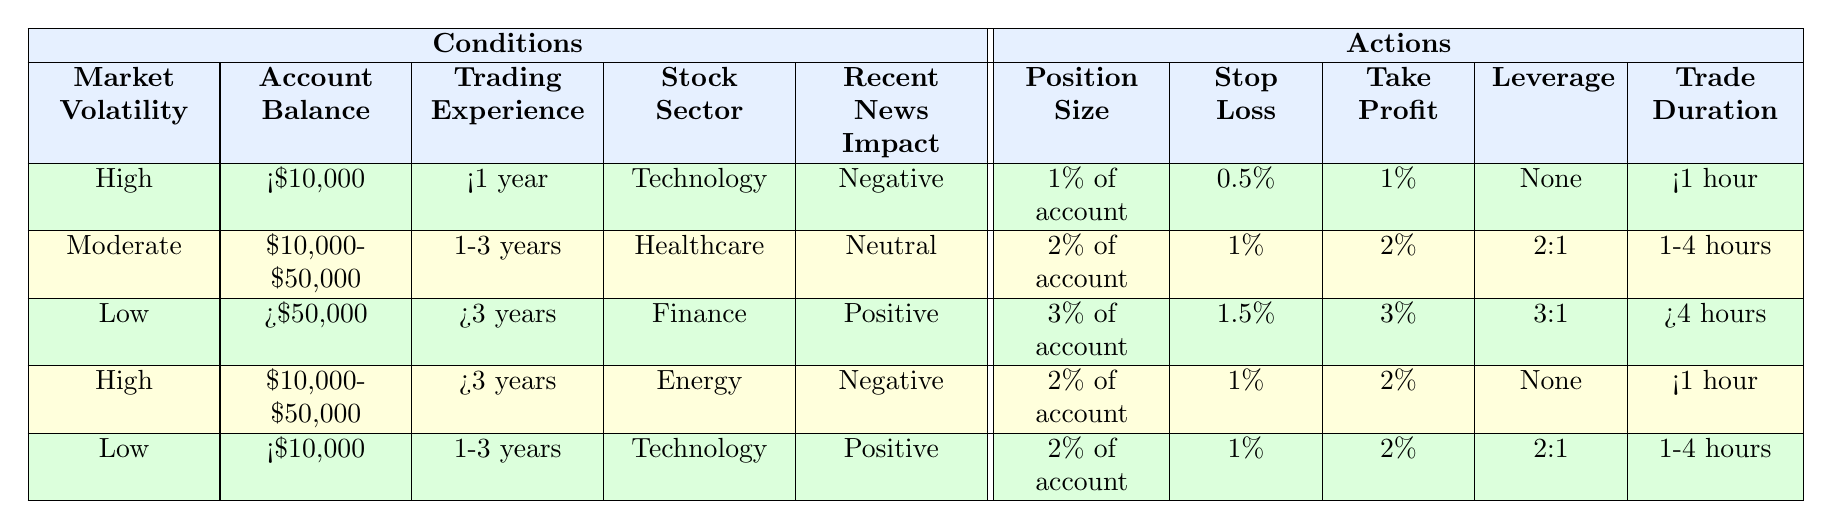What is the recommended position size for someone with less than $10,000 account balance and less than 1 year of trading experience in the technology sector when the market volatility is high and the recent news impact is negative? According to the table, the conditions are: High market volatility, account balance of less than $10,000, trading experience of less than 1 year, sector being Technology, and recent news impact as Negative. The actions for these conditions specify a position size of "1% of account."
Answer: 1% of account What is the stop-loss recommendation for someone with $10,000 to $50,000 account balance and more than 3 years of trading experience if they are trading in the energy sector with negative recent news? The relevant conditions in the table indicate a stop-loss of "1%" for the situation where there is High market volatility, an account balance of $10,000 to $50,000, trading experience over 3 years, Energy sector, and Negative news impact.
Answer: 1% Is it true that for a trader with a more than $50,000 account balance and more than 3 years of experience in finance, the take profit is set to 3%? Referencing the table, the conditions indicate Low market volatility, an account balance greater than $50,000, more than 3 years of experience, Finance sector, and Positive news impact. For these conditions, the take profit is specified as "3%." The statement is true.
Answer: Yes What is the average take profit percentage for trades in the healthcare sector regardless of account balance, trading experience, and news impact? Analyzing the table, there is only one associated percentage for take profit when trading in the healthcare sector, which is "2%" for Moderate market volatility, account balance of $10,000 to $50,000, trading experience of 1-3 years, and Neutral news impact. Since there is only one data point, the average is simply "2%."
Answer: 2% What is the position size for a trader with an account balance less than $10,000 who has 1-3 years of experience in the technology sector under low market volatility with positive news impact? In these conditions, for Low market volatility, account balance of less than $10,000, 1-3 years trading experience, Technology sector, and Positive news impact, the position size specified in the table is "2% of account."
Answer: 2% of account What would be the recommended leverage for a trader with more than $50,000 account balance, more than 3 years of experience, trading in finance during low market volatility with positive news? The conditions would lead to no recommendation for leverage based on the specified conditions. According to the table, when the conditions are Low market volatility, an account balance greater than $50,000, experience over 3 years in Finance, and Positive news impact, the recommended leverage option is "3:1."
Answer: 3:1 